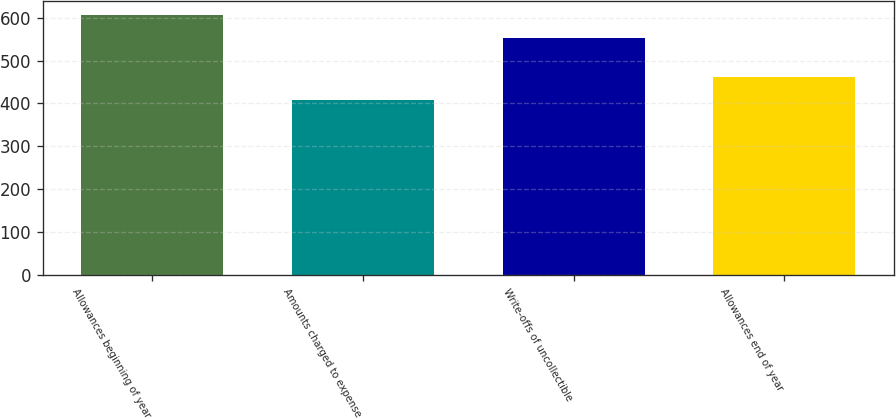<chart> <loc_0><loc_0><loc_500><loc_500><bar_chart><fcel>Allowances beginning of year<fcel>Amounts charged to expense<fcel>Write-offs of uncollectible<fcel>Allowances end of year<nl><fcel>607<fcel>407<fcel>552<fcel>462<nl></chart> 